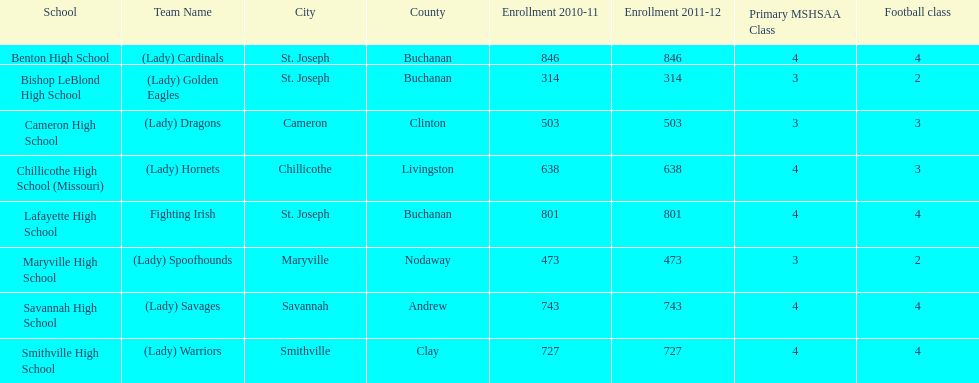How many teams are named after birds? 2. 